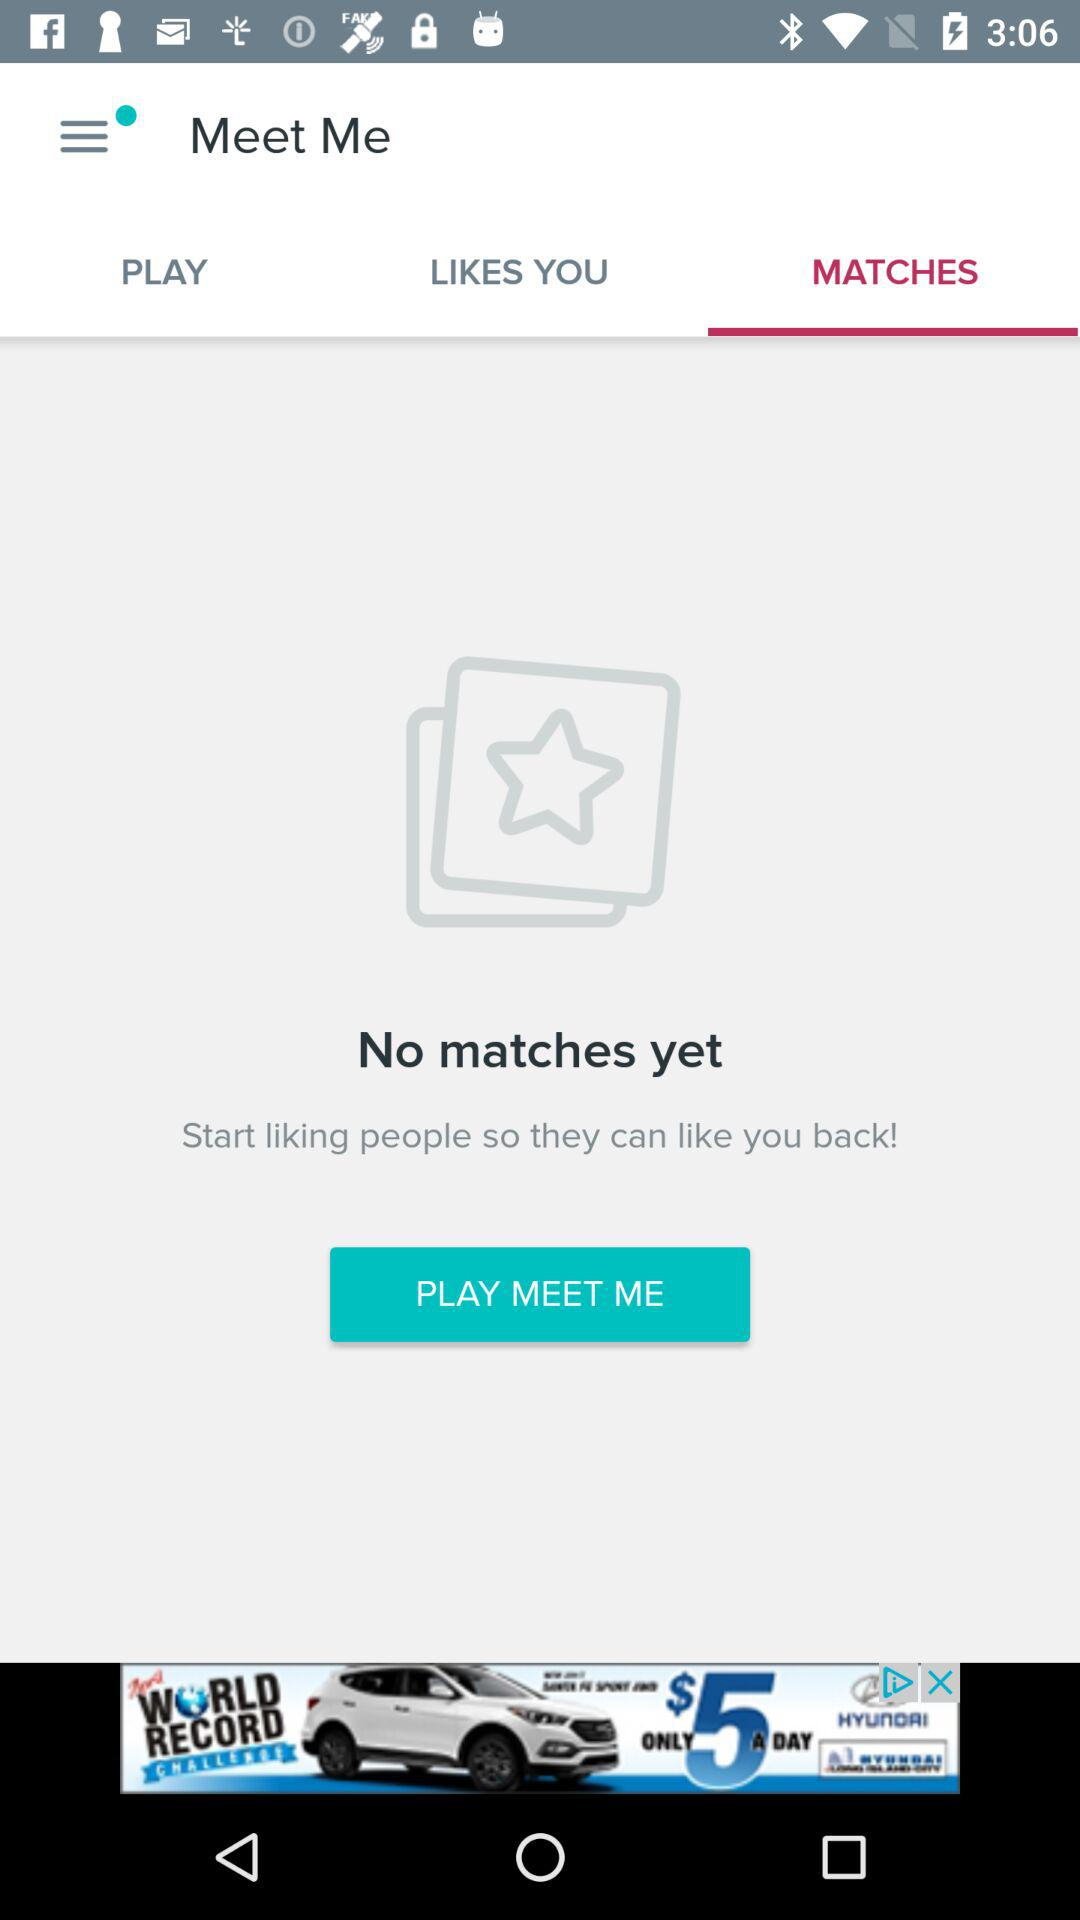Which tab is selected? The selected tab is "MATCHES". 